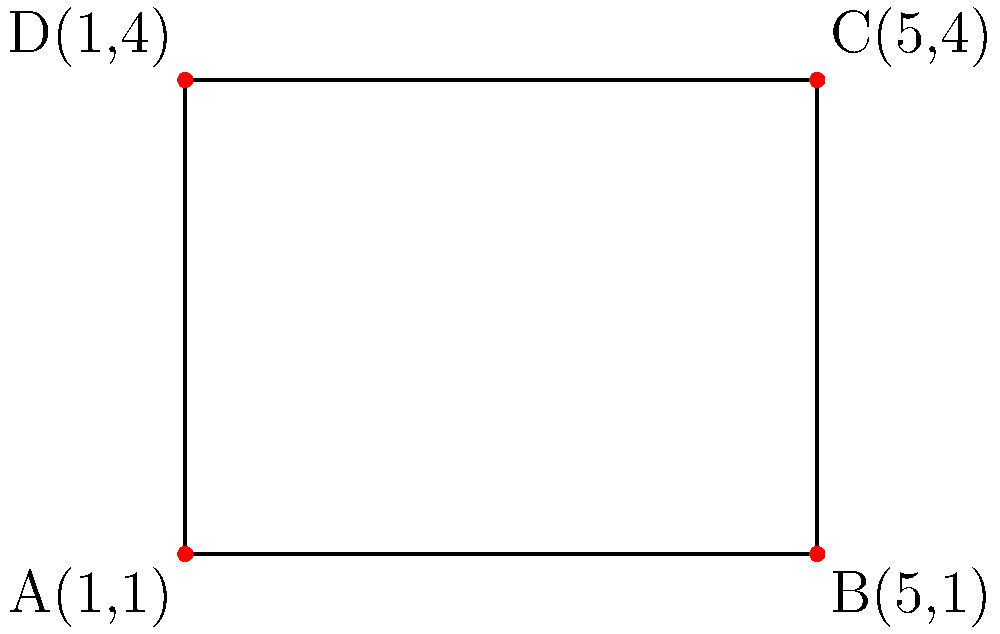Your new compact makeup palette has a rectangular shape. The corners of the palette correspond to the following coordinates on a grid: A(1,1), B(5,1), C(5,4), and D(1,4). Calculate the area of this makeup palette. To find the area of the rectangular makeup palette, we need to follow these steps:

1) First, we need to calculate the length and width of the rectangle.

2) For the length (horizontal side):
   We can use points A and B, or D and C.
   Length = $|x_B - x_A|$ or $|x_C - x_D|$
   Length = $|5 - 1|$ = 4 units

3) For the width (vertical side):
   We can use points A and D, or B and C.
   Width = $|y_D - y_A|$ or $|y_C - y_B|$
   Width = $|4 - 1|$ = 3 units

4) The area of a rectangle is given by the formula:
   Area = length × width

5) Substituting our values:
   Area = 4 × 3 = 12 square units

Therefore, the area of the makeup palette is 12 square units.
Answer: 12 square units 